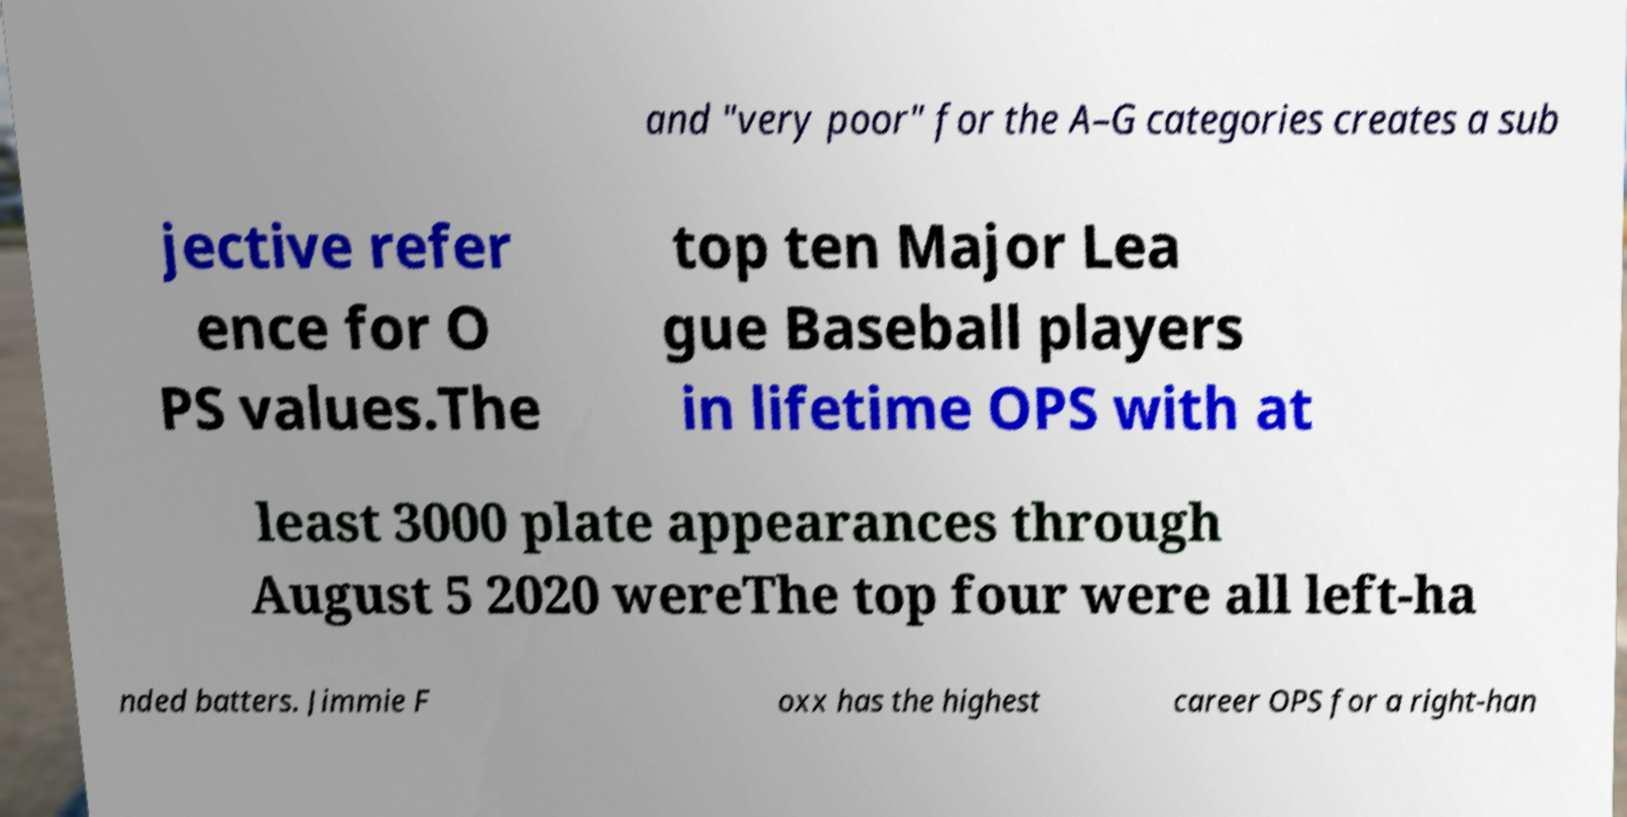Please identify and transcribe the text found in this image. and "very poor" for the A–G categories creates a sub jective refer ence for O PS values.The top ten Major Lea gue Baseball players in lifetime OPS with at least 3000 plate appearances through August 5 2020 wereThe top four were all left-ha nded batters. Jimmie F oxx has the highest career OPS for a right-han 